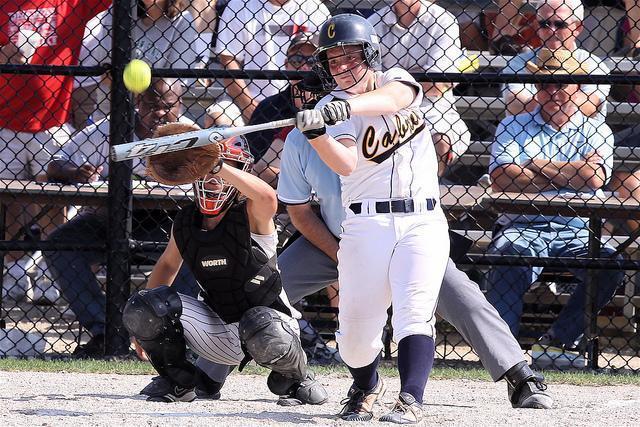How many people are visible?
Give a very brief answer. 10. 